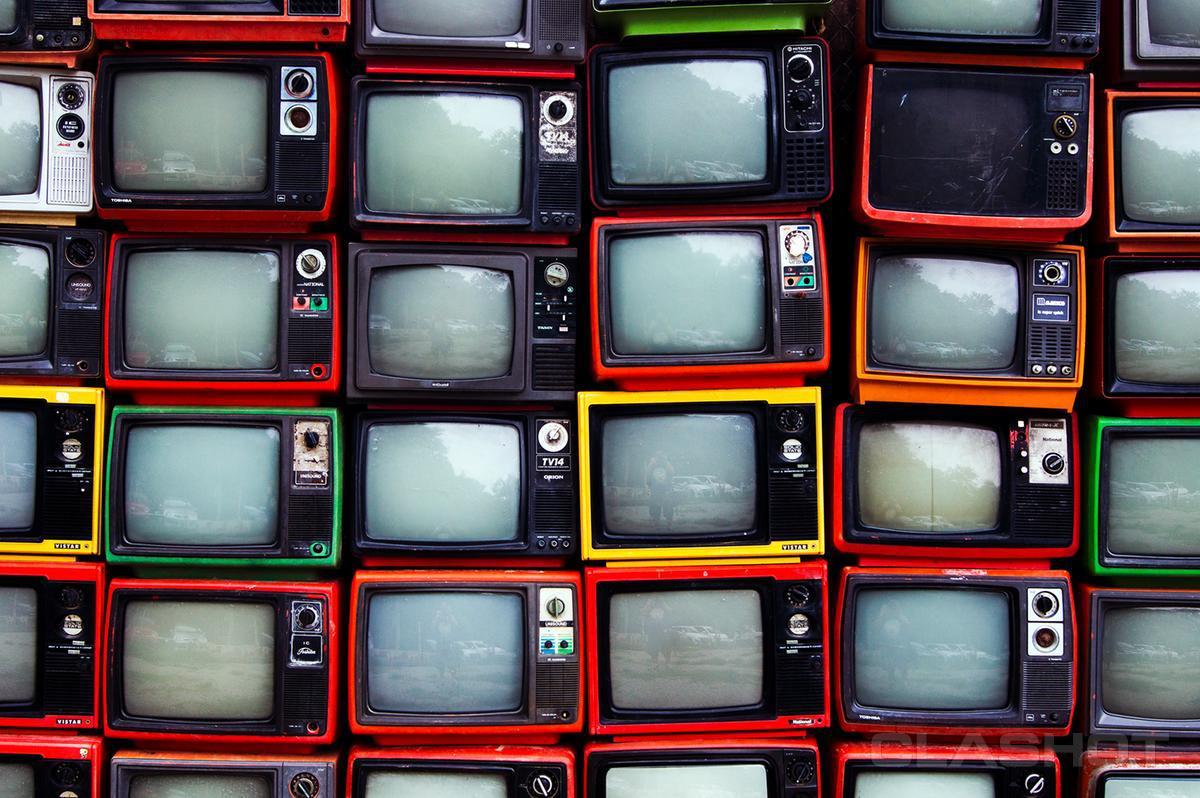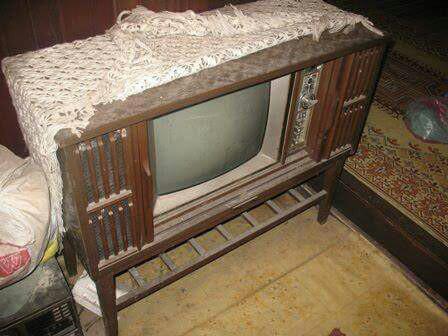The first image is the image on the left, the second image is the image on the right. Analyze the images presented: Is the assertion "There is a single television that is off in the image on the right." valid? Answer yes or no. Yes. The first image is the image on the left, the second image is the image on the right. Examine the images to the left and right. Is the description "An image shows a group of screened appliances stacked on top of one another." accurate? Answer yes or no. Yes. 